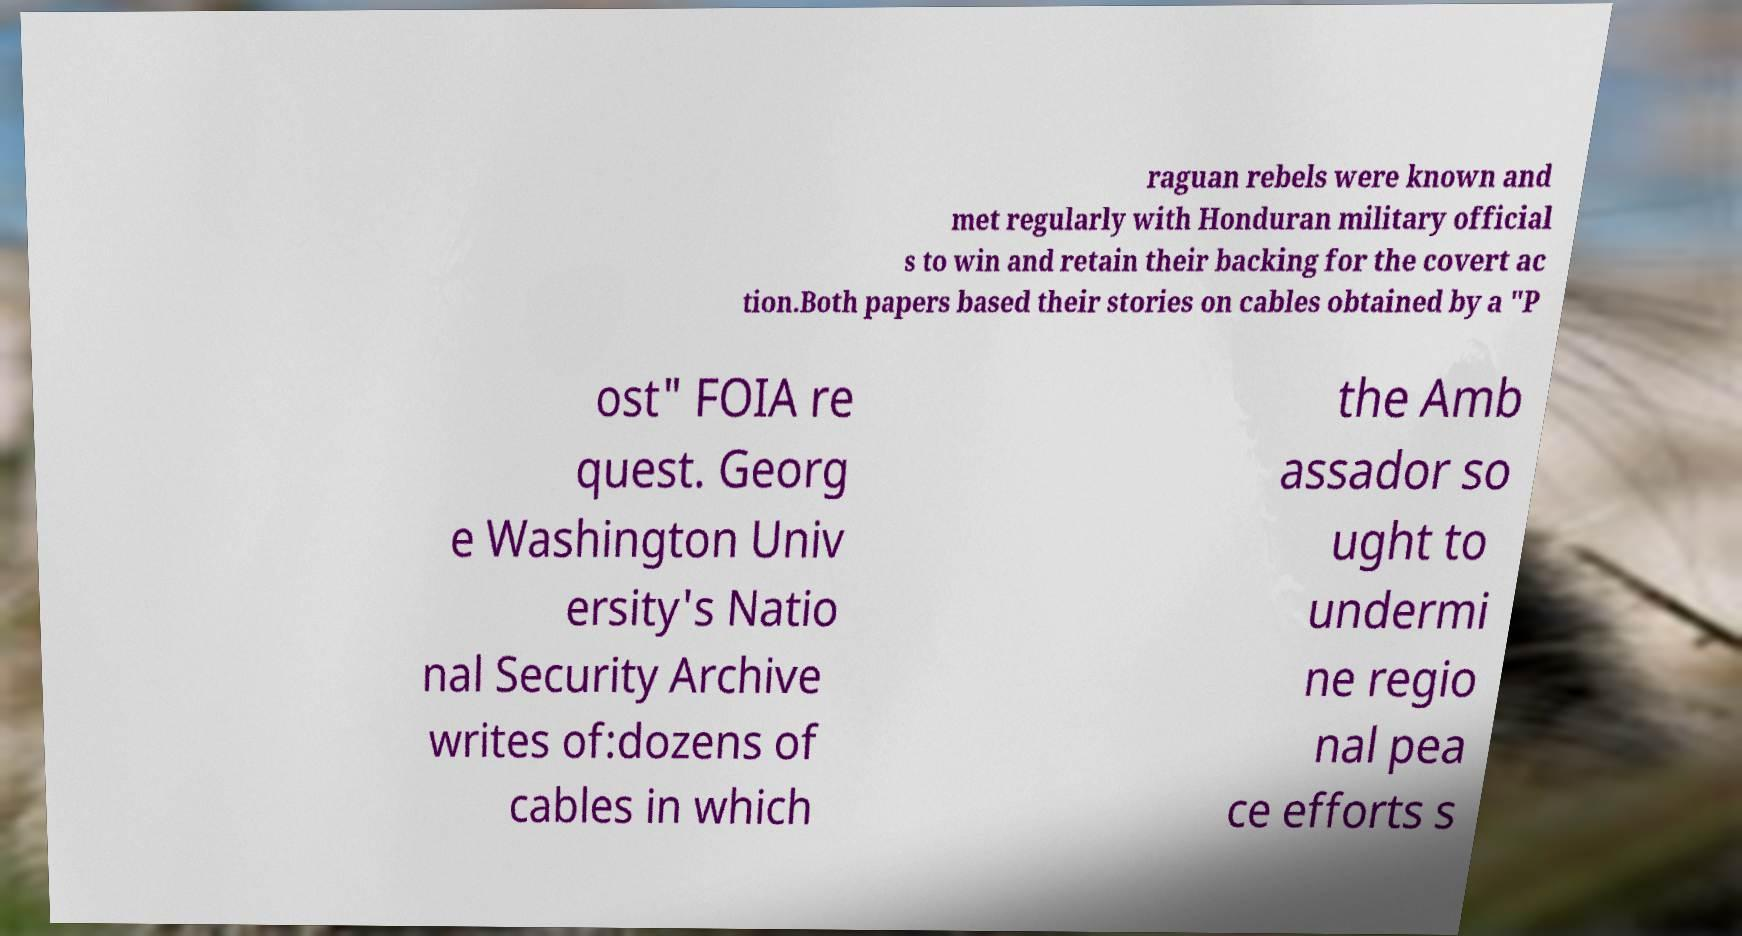Can you read and provide the text displayed in the image?This photo seems to have some interesting text. Can you extract and type it out for me? raguan rebels were known and met regularly with Honduran military official s to win and retain their backing for the covert ac tion.Both papers based their stories on cables obtained by a "P ost" FOIA re quest. Georg e Washington Univ ersity's Natio nal Security Archive writes of:dozens of cables in which the Amb assador so ught to undermi ne regio nal pea ce efforts s 